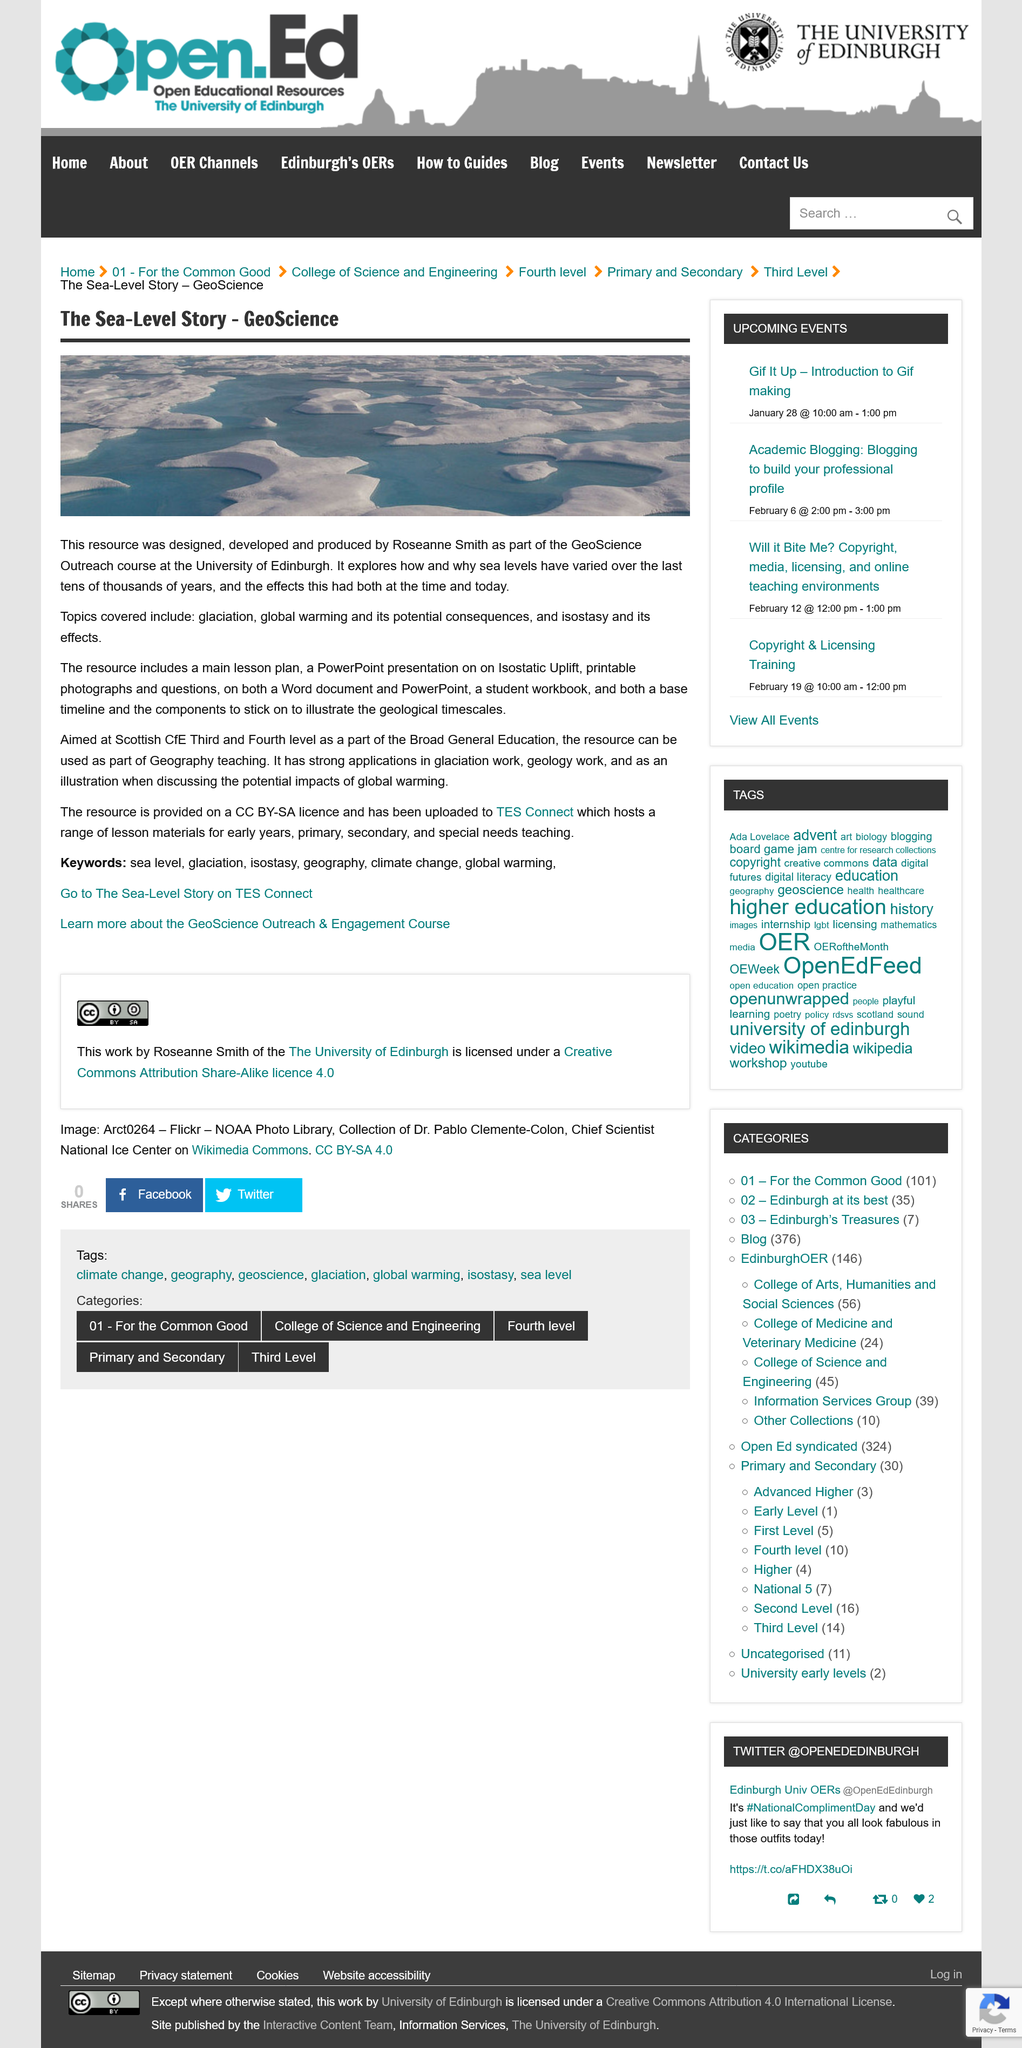Identify some key points in this picture. The GeoScience Outreach course covers topics such as glaciation, global warming and its potential consequences, isostasy and its effects, and more. The provided resource is licensed under a Creative Commons Attribution-ShareAlike (CC BY-SA) license. I, Roseanne Smith, am the designer, developer, and producer of the resource in question. 